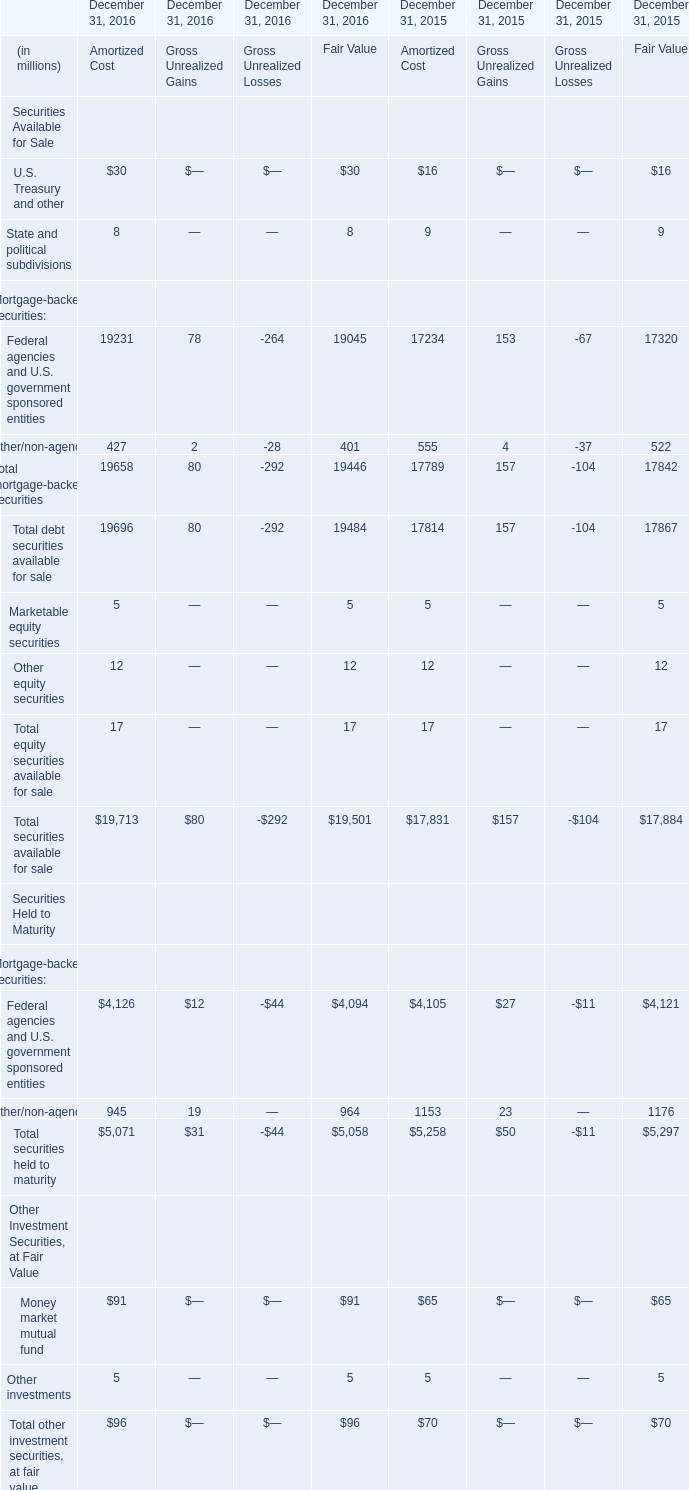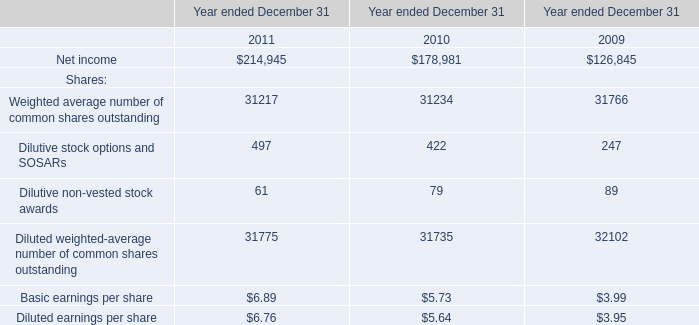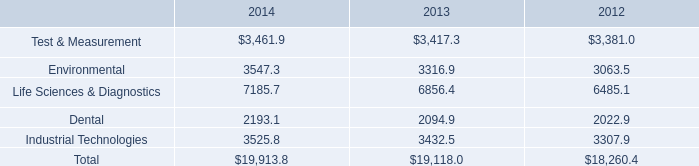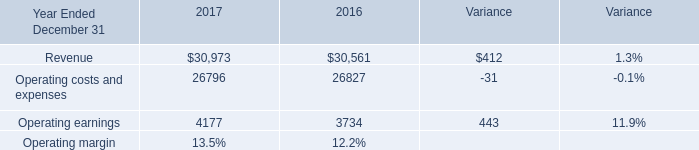What is the ratio of Other/non-agency of Amortized Cost in Table 0 to the Operating earnings in Table 3 in 2016? 
Computations: (945 / 3734)
Answer: 0.25308. 